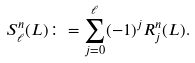Convert formula to latex. <formula><loc_0><loc_0><loc_500><loc_500>S _ { \ell } ^ { n } ( L ) \colon = \sum _ { j = 0 } ^ { \ell } ( - 1 ) ^ { j } R _ { j } ^ { n } ( L ) .</formula> 